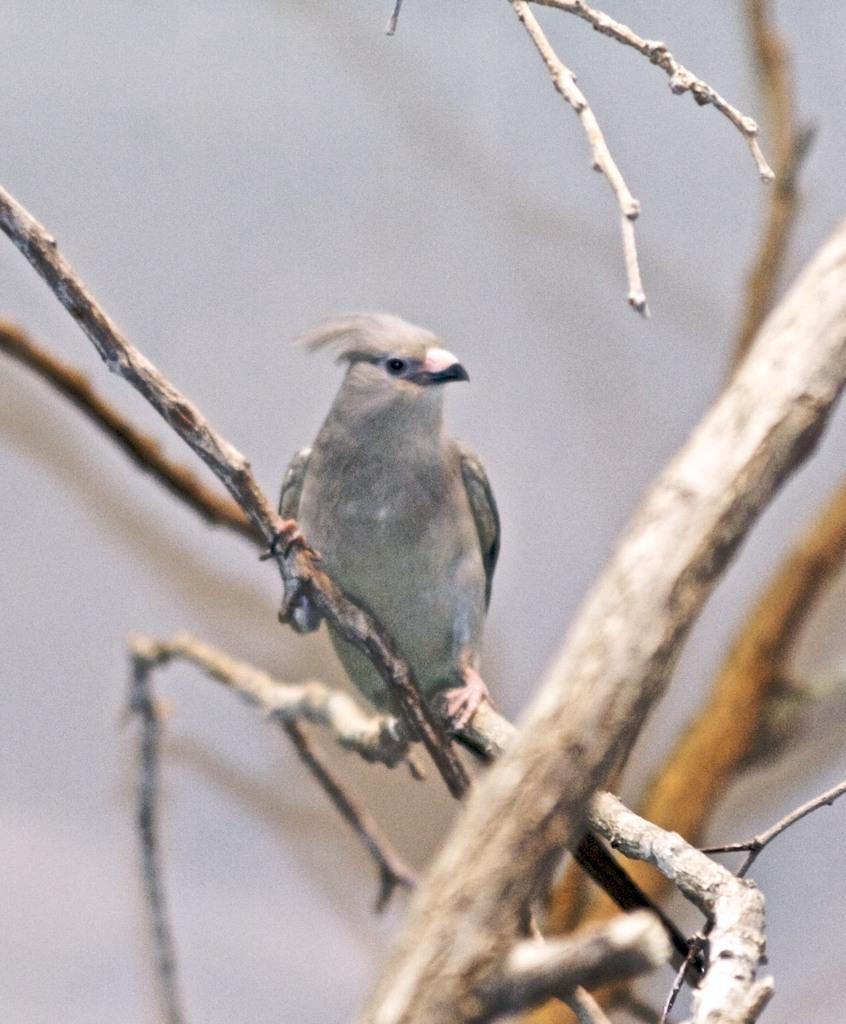In one or two sentences, can you explain what this image depicts? In the image there is a grey color bird standing on a dried tree. 